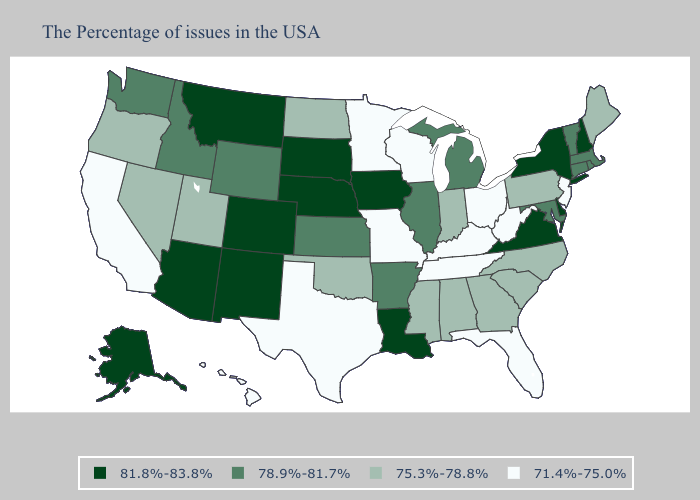What is the value of Virginia?
Short answer required. 81.8%-83.8%. Among the states that border Illinois , does Indiana have the lowest value?
Write a very short answer. No. Does South Carolina have the lowest value in the USA?
Write a very short answer. No. Which states have the lowest value in the USA?
Short answer required. New Jersey, West Virginia, Ohio, Florida, Kentucky, Tennessee, Wisconsin, Missouri, Minnesota, Texas, California, Hawaii. What is the value of Florida?
Write a very short answer. 71.4%-75.0%. What is the value of Tennessee?
Answer briefly. 71.4%-75.0%. What is the value of South Dakota?
Short answer required. 81.8%-83.8%. Does the map have missing data?
Keep it brief. No. Does the first symbol in the legend represent the smallest category?
Write a very short answer. No. What is the value of Florida?
Write a very short answer. 71.4%-75.0%. Which states hav the highest value in the West?
Be succinct. Colorado, New Mexico, Montana, Arizona, Alaska. Which states hav the highest value in the MidWest?
Quick response, please. Iowa, Nebraska, South Dakota. What is the value of Vermont?
Write a very short answer. 78.9%-81.7%. Name the states that have a value in the range 71.4%-75.0%?
Short answer required. New Jersey, West Virginia, Ohio, Florida, Kentucky, Tennessee, Wisconsin, Missouri, Minnesota, Texas, California, Hawaii. Which states have the lowest value in the Northeast?
Give a very brief answer. New Jersey. 